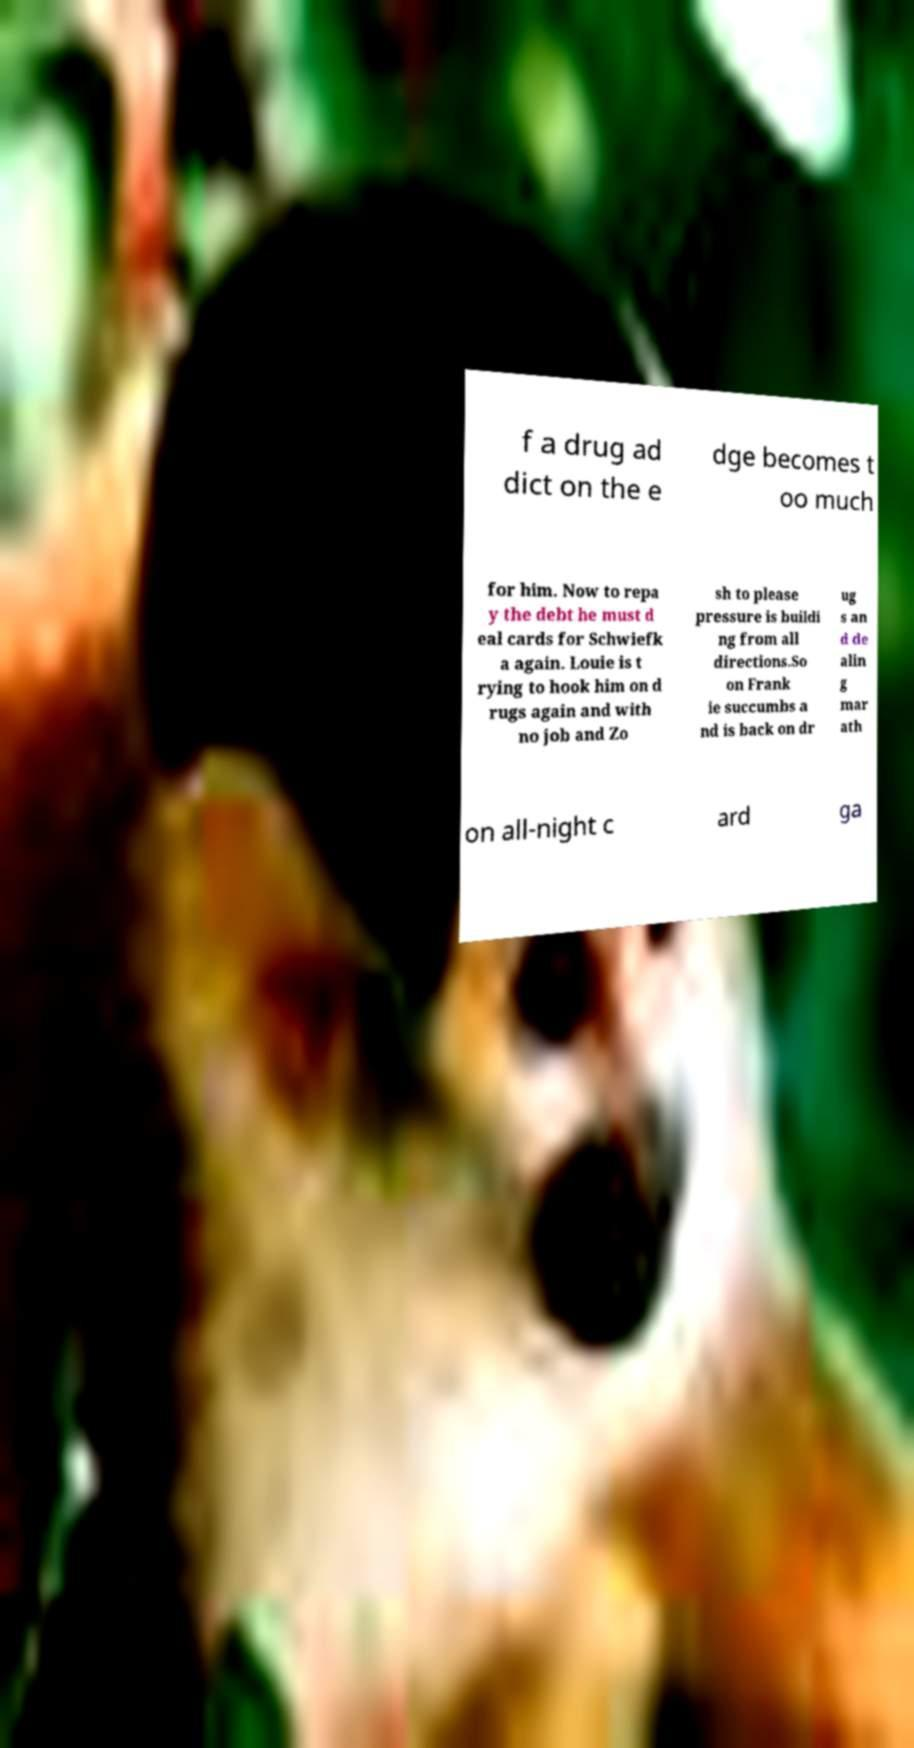Could you extract and type out the text from this image? f a drug ad dict on the e dge becomes t oo much for him. Now to repa y the debt he must d eal cards for Schwiefk a again. Louie is t rying to hook him on d rugs again and with no job and Zo sh to please pressure is buildi ng from all directions.So on Frank ie succumbs a nd is back on dr ug s an d de alin g mar ath on all-night c ard ga 